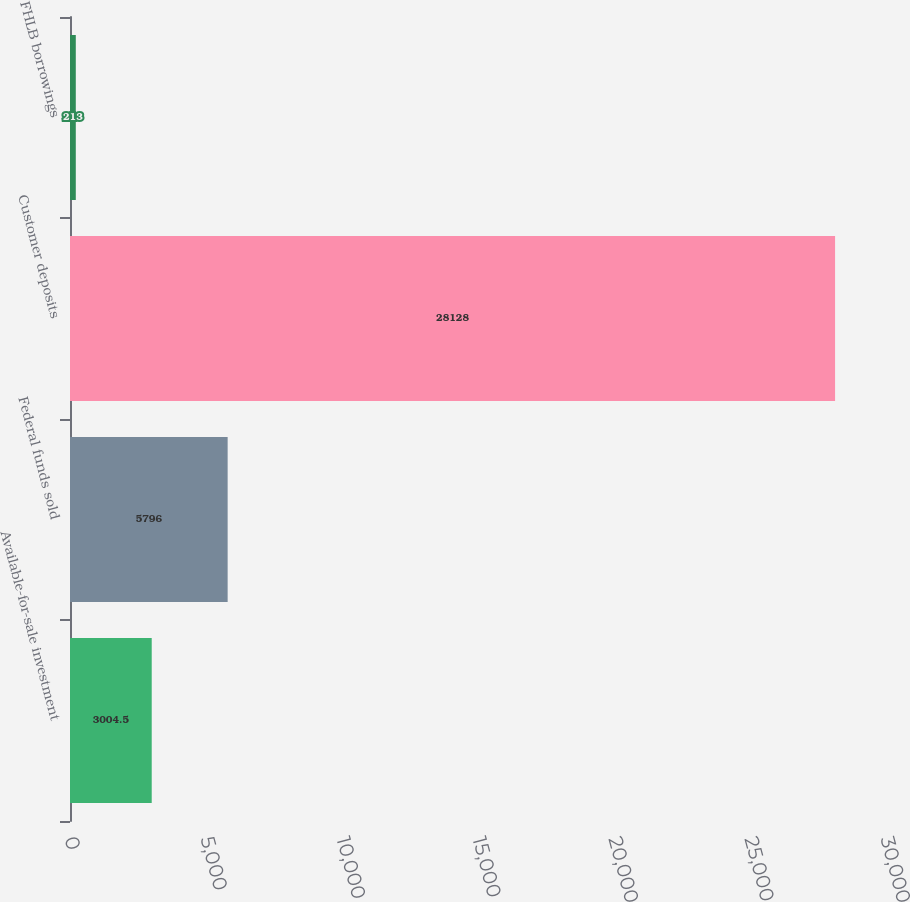Convert chart. <chart><loc_0><loc_0><loc_500><loc_500><bar_chart><fcel>Available-for-sale investment<fcel>Federal funds sold<fcel>Customer deposits<fcel>FHLB borrowings<nl><fcel>3004.5<fcel>5796<fcel>28128<fcel>213<nl></chart> 